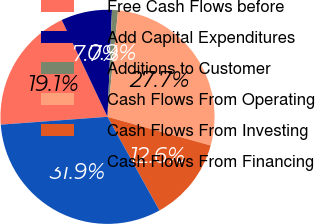<chart> <loc_0><loc_0><loc_500><loc_500><pie_chart><fcel>Free Cash Flows before<fcel>Add Capital Expenditures<fcel>Additions to Customer<fcel>Cash Flows From Operating<fcel>Cash Flows From Investing<fcel>Cash Flows From Financing<nl><fcel>19.14%<fcel>7.69%<fcel>0.91%<fcel>27.74%<fcel>12.63%<fcel>31.89%<nl></chart> 